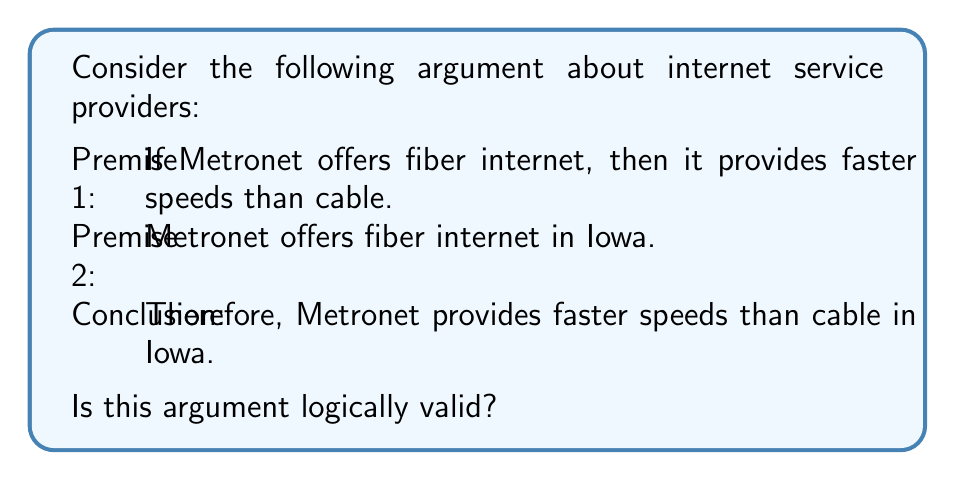Teach me how to tackle this problem. To determine the logical validity of this argument, we need to analyze its structure and use the principles of propositional logic. Let's break down the argument into symbolic form:

Let:
P: Metronet offers fiber internet
Q: Metronet provides faster speeds than cable
R: This is in Iowa

The argument can be symbolized as:

Premise 1: $P \rightarrow Q$
Premise 2: $P \land R$
Conclusion: $Q \land R$

To check for validity, we can use the method of natural deduction:

1. $P \rightarrow Q$ (Premise 1)
2. $P \land R$ (Premise 2)
3. $P$ (Conjunction Elimination from 2)
4. $Q$ (Modus Ponens from 1 and 3)
5. $R$ (Conjunction Elimination from 2)
6. $Q \land R$ (Conjunction Introduction from 4 and 5)

The conclusion $Q \land R$ logically follows from the premises using valid inference rules. Therefore, the argument is logically valid.

It's important to note that logical validity doesn't guarantee truth in the real world. The argument's soundness depends on the truth of its premises. However, given the structure of the argument and the rules of propositional logic, the conclusion necessarily follows if the premises are true.
Answer: The argument is logically valid. 